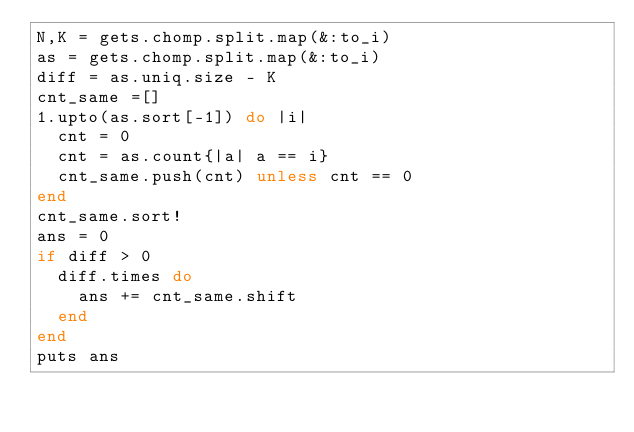<code> <loc_0><loc_0><loc_500><loc_500><_Ruby_>N,K = gets.chomp.split.map(&:to_i)
as = gets.chomp.split.map(&:to_i)
diff = as.uniq.size - K
cnt_same =[]
1.upto(as.sort[-1]) do |i|
  cnt = 0
  cnt = as.count{|a| a == i}
  cnt_same.push(cnt) unless cnt == 0
end
cnt_same.sort!
ans = 0
if diff > 0
  diff.times do
    ans += cnt_same.shift
  end
end
puts ans
</code> 